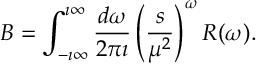Convert formula to latex. <formula><loc_0><loc_0><loc_500><loc_500>B = \int _ { - \imath \infty } ^ { \imath \infty } \frac { d \omega } { 2 \pi \imath } \left ( \frac { s } { \mu ^ { 2 } } \right ) ^ { \omega } R ( \omega ) .</formula> 